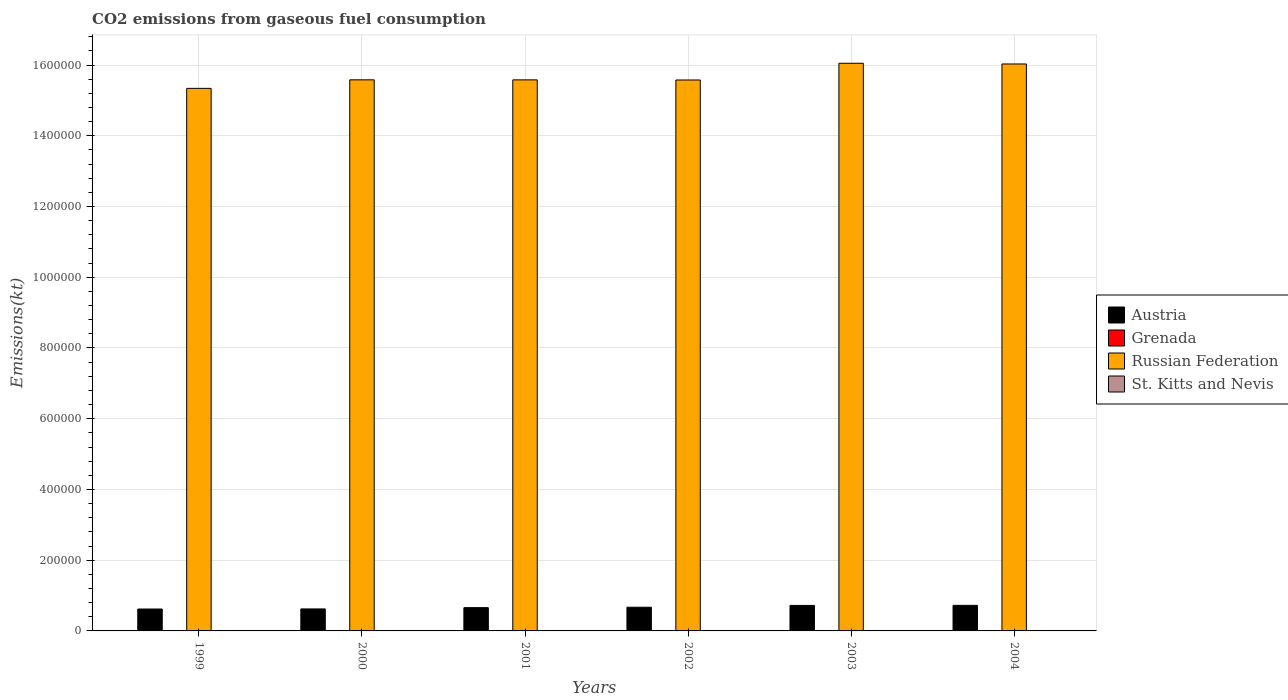How many different coloured bars are there?
Make the answer very short. 4. How many groups of bars are there?
Your answer should be compact. 6. Are the number of bars on each tick of the X-axis equal?
Provide a succinct answer. Yes. How many bars are there on the 3rd tick from the right?
Make the answer very short. 4. What is the amount of CO2 emitted in Austria in 2002?
Your answer should be very brief. 6.70e+04. Across all years, what is the maximum amount of CO2 emitted in Grenada?
Provide a succinct answer. 216.35. Across all years, what is the minimum amount of CO2 emitted in Russian Federation?
Your response must be concise. 1.53e+06. In which year was the amount of CO2 emitted in St. Kitts and Nevis maximum?
Offer a terse response. 2004. In which year was the amount of CO2 emitted in St. Kitts and Nevis minimum?
Offer a very short reply. 1999. What is the total amount of CO2 emitted in St. Kitts and Nevis in the graph?
Your response must be concise. 1034.09. What is the difference between the amount of CO2 emitted in Austria in 2002 and that in 2003?
Keep it short and to the point. -5097.13. What is the difference between the amount of CO2 emitted in Russian Federation in 2003 and the amount of CO2 emitted in Grenada in 1999?
Offer a very short reply. 1.60e+06. What is the average amount of CO2 emitted in Grenada per year?
Your response must be concise. 201.07. In the year 2003, what is the difference between the amount of CO2 emitted in Grenada and amount of CO2 emitted in Austria?
Keep it short and to the point. -7.19e+04. What is the ratio of the amount of CO2 emitted in St. Kitts and Nevis in 2002 to that in 2003?
Ensure brevity in your answer.  0.9. What is the difference between the highest and the second highest amount of CO2 emitted in Grenada?
Give a very brief answer. 11. What is the difference between the highest and the lowest amount of CO2 emitted in Austria?
Your answer should be compact. 1.04e+04. In how many years, is the amount of CO2 emitted in Grenada greater than the average amount of CO2 emitted in Grenada taken over all years?
Your answer should be very brief. 3. Is the sum of the amount of CO2 emitted in Grenada in 2000 and 2001 greater than the maximum amount of CO2 emitted in Austria across all years?
Provide a succinct answer. No. What does the 1st bar from the right in 2003 represents?
Provide a short and direct response. St. Kitts and Nevis. Is it the case that in every year, the sum of the amount of CO2 emitted in Grenada and amount of CO2 emitted in St. Kitts and Nevis is greater than the amount of CO2 emitted in Austria?
Offer a very short reply. No. How many years are there in the graph?
Ensure brevity in your answer.  6. Does the graph contain any zero values?
Ensure brevity in your answer.  No. Does the graph contain grids?
Ensure brevity in your answer.  Yes. How many legend labels are there?
Provide a short and direct response. 4. What is the title of the graph?
Ensure brevity in your answer.  CO2 emissions from gaseous fuel consumption. What is the label or title of the X-axis?
Your response must be concise. Years. What is the label or title of the Y-axis?
Offer a very short reply. Emissions(kt). What is the Emissions(kt) of Austria in 1999?
Offer a terse response. 6.19e+04. What is the Emissions(kt) of Grenada in 1999?
Make the answer very short. 194.35. What is the Emissions(kt) in Russian Federation in 1999?
Give a very brief answer. 1.53e+06. What is the Emissions(kt) of St. Kitts and Nevis in 1999?
Provide a succinct answer. 102.68. What is the Emissions(kt) of Austria in 2000?
Your answer should be very brief. 6.22e+04. What is the Emissions(kt) of Grenada in 2000?
Keep it short and to the point. 190.68. What is the Emissions(kt) of Russian Federation in 2000?
Provide a short and direct response. 1.56e+06. What is the Emissions(kt) of St. Kitts and Nevis in 2000?
Your answer should be compact. 102.68. What is the Emissions(kt) of Austria in 2001?
Make the answer very short. 6.58e+04. What is the Emissions(kt) of Grenada in 2001?
Ensure brevity in your answer.  194.35. What is the Emissions(kt) in Russian Federation in 2001?
Your response must be concise. 1.56e+06. What is the Emissions(kt) in St. Kitts and Nevis in 2001?
Provide a succinct answer. 183.35. What is the Emissions(kt) in Austria in 2002?
Provide a succinct answer. 6.70e+04. What is the Emissions(kt) of Grenada in 2002?
Offer a terse response. 205.35. What is the Emissions(kt) of Russian Federation in 2002?
Offer a very short reply. 1.56e+06. What is the Emissions(kt) of St. Kitts and Nevis in 2002?
Give a very brief answer. 198.02. What is the Emissions(kt) of Austria in 2003?
Keep it short and to the point. 7.21e+04. What is the Emissions(kt) in Grenada in 2003?
Make the answer very short. 216.35. What is the Emissions(kt) in Russian Federation in 2003?
Your response must be concise. 1.60e+06. What is the Emissions(kt) in St. Kitts and Nevis in 2003?
Make the answer very short. 220.02. What is the Emissions(kt) in Austria in 2004?
Ensure brevity in your answer.  7.23e+04. What is the Emissions(kt) of Grenada in 2004?
Ensure brevity in your answer.  205.35. What is the Emissions(kt) of Russian Federation in 2004?
Your response must be concise. 1.60e+06. What is the Emissions(kt) in St. Kitts and Nevis in 2004?
Give a very brief answer. 227.35. Across all years, what is the maximum Emissions(kt) in Austria?
Keep it short and to the point. 7.23e+04. Across all years, what is the maximum Emissions(kt) in Grenada?
Your answer should be very brief. 216.35. Across all years, what is the maximum Emissions(kt) of Russian Federation?
Your answer should be compact. 1.60e+06. Across all years, what is the maximum Emissions(kt) of St. Kitts and Nevis?
Ensure brevity in your answer.  227.35. Across all years, what is the minimum Emissions(kt) in Austria?
Provide a short and direct response. 6.19e+04. Across all years, what is the minimum Emissions(kt) in Grenada?
Keep it short and to the point. 190.68. Across all years, what is the minimum Emissions(kt) of Russian Federation?
Offer a very short reply. 1.53e+06. Across all years, what is the minimum Emissions(kt) in St. Kitts and Nevis?
Provide a short and direct response. 102.68. What is the total Emissions(kt) of Austria in the graph?
Provide a short and direct response. 4.01e+05. What is the total Emissions(kt) of Grenada in the graph?
Provide a succinct answer. 1206.44. What is the total Emissions(kt) of Russian Federation in the graph?
Your answer should be compact. 9.42e+06. What is the total Emissions(kt) in St. Kitts and Nevis in the graph?
Ensure brevity in your answer.  1034.09. What is the difference between the Emissions(kt) of Austria in 1999 and that in 2000?
Provide a short and direct response. -271.36. What is the difference between the Emissions(kt) of Grenada in 1999 and that in 2000?
Ensure brevity in your answer.  3.67. What is the difference between the Emissions(kt) of Russian Federation in 1999 and that in 2000?
Provide a succinct answer. -2.41e+04. What is the difference between the Emissions(kt) in Austria in 1999 and that in 2001?
Provide a short and direct response. -3868.68. What is the difference between the Emissions(kt) in Russian Federation in 1999 and that in 2001?
Keep it short and to the point. -2.40e+04. What is the difference between the Emissions(kt) of St. Kitts and Nevis in 1999 and that in 2001?
Offer a terse response. -80.67. What is the difference between the Emissions(kt) of Austria in 1999 and that in 2002?
Your answer should be compact. -5060.46. What is the difference between the Emissions(kt) of Grenada in 1999 and that in 2002?
Give a very brief answer. -11. What is the difference between the Emissions(kt) in Russian Federation in 1999 and that in 2002?
Your answer should be very brief. -2.37e+04. What is the difference between the Emissions(kt) of St. Kitts and Nevis in 1999 and that in 2002?
Provide a succinct answer. -95.34. What is the difference between the Emissions(kt) of Austria in 1999 and that in 2003?
Give a very brief answer. -1.02e+04. What is the difference between the Emissions(kt) of Grenada in 1999 and that in 2003?
Keep it short and to the point. -22. What is the difference between the Emissions(kt) in Russian Federation in 1999 and that in 2003?
Provide a short and direct response. -7.10e+04. What is the difference between the Emissions(kt) in St. Kitts and Nevis in 1999 and that in 2003?
Offer a very short reply. -117.34. What is the difference between the Emissions(kt) in Austria in 1999 and that in 2004?
Give a very brief answer. -1.04e+04. What is the difference between the Emissions(kt) of Grenada in 1999 and that in 2004?
Provide a succinct answer. -11. What is the difference between the Emissions(kt) of Russian Federation in 1999 and that in 2004?
Make the answer very short. -6.90e+04. What is the difference between the Emissions(kt) of St. Kitts and Nevis in 1999 and that in 2004?
Provide a short and direct response. -124.68. What is the difference between the Emissions(kt) in Austria in 2000 and that in 2001?
Your response must be concise. -3597.33. What is the difference between the Emissions(kt) of Grenada in 2000 and that in 2001?
Your answer should be very brief. -3.67. What is the difference between the Emissions(kt) in Russian Federation in 2000 and that in 2001?
Make the answer very short. 110.01. What is the difference between the Emissions(kt) in St. Kitts and Nevis in 2000 and that in 2001?
Your response must be concise. -80.67. What is the difference between the Emissions(kt) in Austria in 2000 and that in 2002?
Your answer should be compact. -4789.1. What is the difference between the Emissions(kt) of Grenada in 2000 and that in 2002?
Provide a short and direct response. -14.67. What is the difference between the Emissions(kt) in Russian Federation in 2000 and that in 2002?
Give a very brief answer. 451.04. What is the difference between the Emissions(kt) of St. Kitts and Nevis in 2000 and that in 2002?
Provide a succinct answer. -95.34. What is the difference between the Emissions(kt) in Austria in 2000 and that in 2003?
Keep it short and to the point. -9886.23. What is the difference between the Emissions(kt) of Grenada in 2000 and that in 2003?
Provide a short and direct response. -25.67. What is the difference between the Emissions(kt) of Russian Federation in 2000 and that in 2003?
Offer a very short reply. -4.69e+04. What is the difference between the Emissions(kt) of St. Kitts and Nevis in 2000 and that in 2003?
Offer a terse response. -117.34. What is the difference between the Emissions(kt) in Austria in 2000 and that in 2004?
Ensure brevity in your answer.  -1.01e+04. What is the difference between the Emissions(kt) in Grenada in 2000 and that in 2004?
Your response must be concise. -14.67. What is the difference between the Emissions(kt) of Russian Federation in 2000 and that in 2004?
Offer a very short reply. -4.48e+04. What is the difference between the Emissions(kt) in St. Kitts and Nevis in 2000 and that in 2004?
Keep it short and to the point. -124.68. What is the difference between the Emissions(kt) in Austria in 2001 and that in 2002?
Offer a terse response. -1191.78. What is the difference between the Emissions(kt) of Grenada in 2001 and that in 2002?
Your answer should be compact. -11. What is the difference between the Emissions(kt) in Russian Federation in 2001 and that in 2002?
Make the answer very short. 341.03. What is the difference between the Emissions(kt) in St. Kitts and Nevis in 2001 and that in 2002?
Offer a terse response. -14.67. What is the difference between the Emissions(kt) in Austria in 2001 and that in 2003?
Provide a succinct answer. -6288.9. What is the difference between the Emissions(kt) of Grenada in 2001 and that in 2003?
Your answer should be compact. -22. What is the difference between the Emissions(kt) of Russian Federation in 2001 and that in 2003?
Your response must be concise. -4.70e+04. What is the difference between the Emissions(kt) in St. Kitts and Nevis in 2001 and that in 2003?
Your answer should be compact. -36.67. What is the difference between the Emissions(kt) of Austria in 2001 and that in 2004?
Keep it short and to the point. -6486.92. What is the difference between the Emissions(kt) in Grenada in 2001 and that in 2004?
Your answer should be very brief. -11. What is the difference between the Emissions(kt) of Russian Federation in 2001 and that in 2004?
Offer a terse response. -4.50e+04. What is the difference between the Emissions(kt) of St. Kitts and Nevis in 2001 and that in 2004?
Provide a succinct answer. -44. What is the difference between the Emissions(kt) in Austria in 2002 and that in 2003?
Offer a very short reply. -5097.13. What is the difference between the Emissions(kt) of Grenada in 2002 and that in 2003?
Your answer should be very brief. -11. What is the difference between the Emissions(kt) of Russian Federation in 2002 and that in 2003?
Make the answer very short. -4.73e+04. What is the difference between the Emissions(kt) of St. Kitts and Nevis in 2002 and that in 2003?
Offer a terse response. -22. What is the difference between the Emissions(kt) of Austria in 2002 and that in 2004?
Make the answer very short. -5295.15. What is the difference between the Emissions(kt) in Grenada in 2002 and that in 2004?
Provide a succinct answer. 0. What is the difference between the Emissions(kt) in Russian Federation in 2002 and that in 2004?
Your answer should be compact. -4.53e+04. What is the difference between the Emissions(kt) in St. Kitts and Nevis in 2002 and that in 2004?
Make the answer very short. -29.34. What is the difference between the Emissions(kt) of Austria in 2003 and that in 2004?
Offer a terse response. -198.02. What is the difference between the Emissions(kt) in Grenada in 2003 and that in 2004?
Ensure brevity in your answer.  11. What is the difference between the Emissions(kt) in Russian Federation in 2003 and that in 2004?
Give a very brief answer. 2013.18. What is the difference between the Emissions(kt) of St. Kitts and Nevis in 2003 and that in 2004?
Your response must be concise. -7.33. What is the difference between the Emissions(kt) of Austria in 1999 and the Emissions(kt) of Grenada in 2000?
Ensure brevity in your answer.  6.17e+04. What is the difference between the Emissions(kt) of Austria in 1999 and the Emissions(kt) of Russian Federation in 2000?
Your answer should be very brief. -1.50e+06. What is the difference between the Emissions(kt) of Austria in 1999 and the Emissions(kt) of St. Kitts and Nevis in 2000?
Your answer should be compact. 6.18e+04. What is the difference between the Emissions(kt) in Grenada in 1999 and the Emissions(kt) in Russian Federation in 2000?
Your response must be concise. -1.56e+06. What is the difference between the Emissions(kt) of Grenada in 1999 and the Emissions(kt) of St. Kitts and Nevis in 2000?
Provide a succinct answer. 91.67. What is the difference between the Emissions(kt) of Russian Federation in 1999 and the Emissions(kt) of St. Kitts and Nevis in 2000?
Provide a short and direct response. 1.53e+06. What is the difference between the Emissions(kt) of Austria in 1999 and the Emissions(kt) of Grenada in 2001?
Make the answer very short. 6.17e+04. What is the difference between the Emissions(kt) in Austria in 1999 and the Emissions(kt) in Russian Federation in 2001?
Give a very brief answer. -1.50e+06. What is the difference between the Emissions(kt) in Austria in 1999 and the Emissions(kt) in St. Kitts and Nevis in 2001?
Provide a short and direct response. 6.17e+04. What is the difference between the Emissions(kt) of Grenada in 1999 and the Emissions(kt) of Russian Federation in 2001?
Your answer should be compact. -1.56e+06. What is the difference between the Emissions(kt) of Grenada in 1999 and the Emissions(kt) of St. Kitts and Nevis in 2001?
Your response must be concise. 11. What is the difference between the Emissions(kt) in Russian Federation in 1999 and the Emissions(kt) in St. Kitts and Nevis in 2001?
Provide a short and direct response. 1.53e+06. What is the difference between the Emissions(kt) of Austria in 1999 and the Emissions(kt) of Grenada in 2002?
Ensure brevity in your answer.  6.17e+04. What is the difference between the Emissions(kt) in Austria in 1999 and the Emissions(kt) in Russian Federation in 2002?
Make the answer very short. -1.50e+06. What is the difference between the Emissions(kt) in Austria in 1999 and the Emissions(kt) in St. Kitts and Nevis in 2002?
Your answer should be very brief. 6.17e+04. What is the difference between the Emissions(kt) of Grenada in 1999 and the Emissions(kt) of Russian Federation in 2002?
Provide a succinct answer. -1.56e+06. What is the difference between the Emissions(kt) in Grenada in 1999 and the Emissions(kt) in St. Kitts and Nevis in 2002?
Make the answer very short. -3.67. What is the difference between the Emissions(kt) in Russian Federation in 1999 and the Emissions(kt) in St. Kitts and Nevis in 2002?
Make the answer very short. 1.53e+06. What is the difference between the Emissions(kt) of Austria in 1999 and the Emissions(kt) of Grenada in 2003?
Ensure brevity in your answer.  6.17e+04. What is the difference between the Emissions(kt) of Austria in 1999 and the Emissions(kt) of Russian Federation in 2003?
Your response must be concise. -1.54e+06. What is the difference between the Emissions(kt) in Austria in 1999 and the Emissions(kt) in St. Kitts and Nevis in 2003?
Your answer should be very brief. 6.17e+04. What is the difference between the Emissions(kt) in Grenada in 1999 and the Emissions(kt) in Russian Federation in 2003?
Your answer should be very brief. -1.60e+06. What is the difference between the Emissions(kt) in Grenada in 1999 and the Emissions(kt) in St. Kitts and Nevis in 2003?
Ensure brevity in your answer.  -25.67. What is the difference between the Emissions(kt) in Russian Federation in 1999 and the Emissions(kt) in St. Kitts and Nevis in 2003?
Your answer should be compact. 1.53e+06. What is the difference between the Emissions(kt) in Austria in 1999 and the Emissions(kt) in Grenada in 2004?
Give a very brief answer. 6.17e+04. What is the difference between the Emissions(kt) in Austria in 1999 and the Emissions(kt) in Russian Federation in 2004?
Your answer should be compact. -1.54e+06. What is the difference between the Emissions(kt) in Austria in 1999 and the Emissions(kt) in St. Kitts and Nevis in 2004?
Provide a short and direct response. 6.17e+04. What is the difference between the Emissions(kt) of Grenada in 1999 and the Emissions(kt) of Russian Federation in 2004?
Offer a very short reply. -1.60e+06. What is the difference between the Emissions(kt) in Grenada in 1999 and the Emissions(kt) in St. Kitts and Nevis in 2004?
Offer a very short reply. -33. What is the difference between the Emissions(kt) in Russian Federation in 1999 and the Emissions(kt) in St. Kitts and Nevis in 2004?
Make the answer very short. 1.53e+06. What is the difference between the Emissions(kt) in Austria in 2000 and the Emissions(kt) in Grenada in 2001?
Ensure brevity in your answer.  6.20e+04. What is the difference between the Emissions(kt) in Austria in 2000 and the Emissions(kt) in Russian Federation in 2001?
Your answer should be very brief. -1.50e+06. What is the difference between the Emissions(kt) in Austria in 2000 and the Emissions(kt) in St. Kitts and Nevis in 2001?
Your answer should be very brief. 6.20e+04. What is the difference between the Emissions(kt) in Grenada in 2000 and the Emissions(kt) in Russian Federation in 2001?
Your answer should be compact. -1.56e+06. What is the difference between the Emissions(kt) in Grenada in 2000 and the Emissions(kt) in St. Kitts and Nevis in 2001?
Ensure brevity in your answer.  7.33. What is the difference between the Emissions(kt) of Russian Federation in 2000 and the Emissions(kt) of St. Kitts and Nevis in 2001?
Your answer should be compact. 1.56e+06. What is the difference between the Emissions(kt) in Austria in 2000 and the Emissions(kt) in Grenada in 2002?
Provide a succinct answer. 6.20e+04. What is the difference between the Emissions(kt) of Austria in 2000 and the Emissions(kt) of Russian Federation in 2002?
Keep it short and to the point. -1.50e+06. What is the difference between the Emissions(kt) of Austria in 2000 and the Emissions(kt) of St. Kitts and Nevis in 2002?
Offer a very short reply. 6.20e+04. What is the difference between the Emissions(kt) of Grenada in 2000 and the Emissions(kt) of Russian Federation in 2002?
Provide a succinct answer. -1.56e+06. What is the difference between the Emissions(kt) of Grenada in 2000 and the Emissions(kt) of St. Kitts and Nevis in 2002?
Your answer should be very brief. -7.33. What is the difference between the Emissions(kt) in Russian Federation in 2000 and the Emissions(kt) in St. Kitts and Nevis in 2002?
Provide a short and direct response. 1.56e+06. What is the difference between the Emissions(kt) in Austria in 2000 and the Emissions(kt) in Grenada in 2003?
Your answer should be compact. 6.20e+04. What is the difference between the Emissions(kt) of Austria in 2000 and the Emissions(kt) of Russian Federation in 2003?
Your answer should be very brief. -1.54e+06. What is the difference between the Emissions(kt) of Austria in 2000 and the Emissions(kt) of St. Kitts and Nevis in 2003?
Keep it short and to the point. 6.20e+04. What is the difference between the Emissions(kt) of Grenada in 2000 and the Emissions(kt) of Russian Federation in 2003?
Ensure brevity in your answer.  -1.60e+06. What is the difference between the Emissions(kt) in Grenada in 2000 and the Emissions(kt) in St. Kitts and Nevis in 2003?
Provide a succinct answer. -29.34. What is the difference between the Emissions(kt) in Russian Federation in 2000 and the Emissions(kt) in St. Kitts and Nevis in 2003?
Your answer should be compact. 1.56e+06. What is the difference between the Emissions(kt) of Austria in 2000 and the Emissions(kt) of Grenada in 2004?
Keep it short and to the point. 6.20e+04. What is the difference between the Emissions(kt) of Austria in 2000 and the Emissions(kt) of Russian Federation in 2004?
Make the answer very short. -1.54e+06. What is the difference between the Emissions(kt) of Austria in 2000 and the Emissions(kt) of St. Kitts and Nevis in 2004?
Ensure brevity in your answer.  6.20e+04. What is the difference between the Emissions(kt) of Grenada in 2000 and the Emissions(kt) of Russian Federation in 2004?
Offer a very short reply. -1.60e+06. What is the difference between the Emissions(kt) in Grenada in 2000 and the Emissions(kt) in St. Kitts and Nevis in 2004?
Your response must be concise. -36.67. What is the difference between the Emissions(kt) in Russian Federation in 2000 and the Emissions(kt) in St. Kitts and Nevis in 2004?
Offer a terse response. 1.56e+06. What is the difference between the Emissions(kt) of Austria in 2001 and the Emissions(kt) of Grenada in 2002?
Offer a very short reply. 6.56e+04. What is the difference between the Emissions(kt) of Austria in 2001 and the Emissions(kt) of Russian Federation in 2002?
Give a very brief answer. -1.49e+06. What is the difference between the Emissions(kt) in Austria in 2001 and the Emissions(kt) in St. Kitts and Nevis in 2002?
Ensure brevity in your answer.  6.56e+04. What is the difference between the Emissions(kt) in Grenada in 2001 and the Emissions(kt) in Russian Federation in 2002?
Make the answer very short. -1.56e+06. What is the difference between the Emissions(kt) of Grenada in 2001 and the Emissions(kt) of St. Kitts and Nevis in 2002?
Your answer should be very brief. -3.67. What is the difference between the Emissions(kt) in Russian Federation in 2001 and the Emissions(kt) in St. Kitts and Nevis in 2002?
Your response must be concise. 1.56e+06. What is the difference between the Emissions(kt) in Austria in 2001 and the Emissions(kt) in Grenada in 2003?
Provide a succinct answer. 6.56e+04. What is the difference between the Emissions(kt) in Austria in 2001 and the Emissions(kt) in Russian Federation in 2003?
Provide a short and direct response. -1.54e+06. What is the difference between the Emissions(kt) of Austria in 2001 and the Emissions(kt) of St. Kitts and Nevis in 2003?
Provide a succinct answer. 6.56e+04. What is the difference between the Emissions(kt) in Grenada in 2001 and the Emissions(kt) in Russian Federation in 2003?
Offer a very short reply. -1.60e+06. What is the difference between the Emissions(kt) of Grenada in 2001 and the Emissions(kt) of St. Kitts and Nevis in 2003?
Provide a succinct answer. -25.67. What is the difference between the Emissions(kt) of Russian Federation in 2001 and the Emissions(kt) of St. Kitts and Nevis in 2003?
Your answer should be very brief. 1.56e+06. What is the difference between the Emissions(kt) in Austria in 2001 and the Emissions(kt) in Grenada in 2004?
Your answer should be compact. 6.56e+04. What is the difference between the Emissions(kt) of Austria in 2001 and the Emissions(kt) of Russian Federation in 2004?
Provide a short and direct response. -1.54e+06. What is the difference between the Emissions(kt) of Austria in 2001 and the Emissions(kt) of St. Kitts and Nevis in 2004?
Your answer should be compact. 6.56e+04. What is the difference between the Emissions(kt) of Grenada in 2001 and the Emissions(kt) of Russian Federation in 2004?
Offer a very short reply. -1.60e+06. What is the difference between the Emissions(kt) of Grenada in 2001 and the Emissions(kt) of St. Kitts and Nevis in 2004?
Provide a succinct answer. -33. What is the difference between the Emissions(kt) of Russian Federation in 2001 and the Emissions(kt) of St. Kitts and Nevis in 2004?
Make the answer very short. 1.56e+06. What is the difference between the Emissions(kt) in Austria in 2002 and the Emissions(kt) in Grenada in 2003?
Provide a succinct answer. 6.68e+04. What is the difference between the Emissions(kt) of Austria in 2002 and the Emissions(kt) of Russian Federation in 2003?
Your answer should be very brief. -1.54e+06. What is the difference between the Emissions(kt) in Austria in 2002 and the Emissions(kt) in St. Kitts and Nevis in 2003?
Give a very brief answer. 6.68e+04. What is the difference between the Emissions(kt) of Grenada in 2002 and the Emissions(kt) of Russian Federation in 2003?
Your answer should be compact. -1.60e+06. What is the difference between the Emissions(kt) of Grenada in 2002 and the Emissions(kt) of St. Kitts and Nevis in 2003?
Provide a succinct answer. -14.67. What is the difference between the Emissions(kt) of Russian Federation in 2002 and the Emissions(kt) of St. Kitts and Nevis in 2003?
Your answer should be very brief. 1.56e+06. What is the difference between the Emissions(kt) in Austria in 2002 and the Emissions(kt) in Grenada in 2004?
Your answer should be compact. 6.68e+04. What is the difference between the Emissions(kt) of Austria in 2002 and the Emissions(kt) of Russian Federation in 2004?
Make the answer very short. -1.54e+06. What is the difference between the Emissions(kt) of Austria in 2002 and the Emissions(kt) of St. Kitts and Nevis in 2004?
Ensure brevity in your answer.  6.68e+04. What is the difference between the Emissions(kt) in Grenada in 2002 and the Emissions(kt) in Russian Federation in 2004?
Offer a very short reply. -1.60e+06. What is the difference between the Emissions(kt) of Grenada in 2002 and the Emissions(kt) of St. Kitts and Nevis in 2004?
Provide a short and direct response. -22. What is the difference between the Emissions(kt) in Russian Federation in 2002 and the Emissions(kt) in St. Kitts and Nevis in 2004?
Provide a short and direct response. 1.56e+06. What is the difference between the Emissions(kt) in Austria in 2003 and the Emissions(kt) in Grenada in 2004?
Your answer should be compact. 7.19e+04. What is the difference between the Emissions(kt) of Austria in 2003 and the Emissions(kt) of Russian Federation in 2004?
Offer a terse response. -1.53e+06. What is the difference between the Emissions(kt) of Austria in 2003 and the Emissions(kt) of St. Kitts and Nevis in 2004?
Give a very brief answer. 7.18e+04. What is the difference between the Emissions(kt) in Grenada in 2003 and the Emissions(kt) in Russian Federation in 2004?
Your response must be concise. -1.60e+06. What is the difference between the Emissions(kt) of Grenada in 2003 and the Emissions(kt) of St. Kitts and Nevis in 2004?
Your answer should be very brief. -11. What is the difference between the Emissions(kt) of Russian Federation in 2003 and the Emissions(kt) of St. Kitts and Nevis in 2004?
Your answer should be compact. 1.60e+06. What is the average Emissions(kt) in Austria per year?
Provide a short and direct response. 6.69e+04. What is the average Emissions(kt) of Grenada per year?
Ensure brevity in your answer.  201.07. What is the average Emissions(kt) in Russian Federation per year?
Offer a terse response. 1.57e+06. What is the average Emissions(kt) in St. Kitts and Nevis per year?
Keep it short and to the point. 172.35. In the year 1999, what is the difference between the Emissions(kt) of Austria and Emissions(kt) of Grenada?
Make the answer very short. 6.17e+04. In the year 1999, what is the difference between the Emissions(kt) in Austria and Emissions(kt) in Russian Federation?
Make the answer very short. -1.47e+06. In the year 1999, what is the difference between the Emissions(kt) in Austria and Emissions(kt) in St. Kitts and Nevis?
Your response must be concise. 6.18e+04. In the year 1999, what is the difference between the Emissions(kt) of Grenada and Emissions(kt) of Russian Federation?
Your answer should be very brief. -1.53e+06. In the year 1999, what is the difference between the Emissions(kt) of Grenada and Emissions(kt) of St. Kitts and Nevis?
Ensure brevity in your answer.  91.67. In the year 1999, what is the difference between the Emissions(kt) of Russian Federation and Emissions(kt) of St. Kitts and Nevis?
Give a very brief answer. 1.53e+06. In the year 2000, what is the difference between the Emissions(kt) in Austria and Emissions(kt) in Grenada?
Your response must be concise. 6.20e+04. In the year 2000, what is the difference between the Emissions(kt) in Austria and Emissions(kt) in Russian Federation?
Offer a terse response. -1.50e+06. In the year 2000, what is the difference between the Emissions(kt) of Austria and Emissions(kt) of St. Kitts and Nevis?
Offer a terse response. 6.21e+04. In the year 2000, what is the difference between the Emissions(kt) of Grenada and Emissions(kt) of Russian Federation?
Your answer should be compact. -1.56e+06. In the year 2000, what is the difference between the Emissions(kt) of Grenada and Emissions(kt) of St. Kitts and Nevis?
Offer a terse response. 88.01. In the year 2000, what is the difference between the Emissions(kt) of Russian Federation and Emissions(kt) of St. Kitts and Nevis?
Provide a short and direct response. 1.56e+06. In the year 2001, what is the difference between the Emissions(kt) in Austria and Emissions(kt) in Grenada?
Provide a succinct answer. 6.56e+04. In the year 2001, what is the difference between the Emissions(kt) in Austria and Emissions(kt) in Russian Federation?
Ensure brevity in your answer.  -1.49e+06. In the year 2001, what is the difference between the Emissions(kt) in Austria and Emissions(kt) in St. Kitts and Nevis?
Your response must be concise. 6.56e+04. In the year 2001, what is the difference between the Emissions(kt) in Grenada and Emissions(kt) in Russian Federation?
Your response must be concise. -1.56e+06. In the year 2001, what is the difference between the Emissions(kt) in Grenada and Emissions(kt) in St. Kitts and Nevis?
Make the answer very short. 11. In the year 2001, what is the difference between the Emissions(kt) in Russian Federation and Emissions(kt) in St. Kitts and Nevis?
Give a very brief answer. 1.56e+06. In the year 2002, what is the difference between the Emissions(kt) in Austria and Emissions(kt) in Grenada?
Give a very brief answer. 6.68e+04. In the year 2002, what is the difference between the Emissions(kt) of Austria and Emissions(kt) of Russian Federation?
Give a very brief answer. -1.49e+06. In the year 2002, what is the difference between the Emissions(kt) in Austria and Emissions(kt) in St. Kitts and Nevis?
Provide a succinct answer. 6.68e+04. In the year 2002, what is the difference between the Emissions(kt) in Grenada and Emissions(kt) in Russian Federation?
Give a very brief answer. -1.56e+06. In the year 2002, what is the difference between the Emissions(kt) in Grenada and Emissions(kt) in St. Kitts and Nevis?
Provide a short and direct response. 7.33. In the year 2002, what is the difference between the Emissions(kt) of Russian Federation and Emissions(kt) of St. Kitts and Nevis?
Provide a short and direct response. 1.56e+06. In the year 2003, what is the difference between the Emissions(kt) of Austria and Emissions(kt) of Grenada?
Your answer should be very brief. 7.19e+04. In the year 2003, what is the difference between the Emissions(kt) of Austria and Emissions(kt) of Russian Federation?
Offer a terse response. -1.53e+06. In the year 2003, what is the difference between the Emissions(kt) of Austria and Emissions(kt) of St. Kitts and Nevis?
Provide a short and direct response. 7.19e+04. In the year 2003, what is the difference between the Emissions(kt) in Grenada and Emissions(kt) in Russian Federation?
Ensure brevity in your answer.  -1.60e+06. In the year 2003, what is the difference between the Emissions(kt) of Grenada and Emissions(kt) of St. Kitts and Nevis?
Offer a terse response. -3.67. In the year 2003, what is the difference between the Emissions(kt) of Russian Federation and Emissions(kt) of St. Kitts and Nevis?
Your response must be concise. 1.60e+06. In the year 2004, what is the difference between the Emissions(kt) in Austria and Emissions(kt) in Grenada?
Your answer should be compact. 7.21e+04. In the year 2004, what is the difference between the Emissions(kt) in Austria and Emissions(kt) in Russian Federation?
Provide a short and direct response. -1.53e+06. In the year 2004, what is the difference between the Emissions(kt) of Austria and Emissions(kt) of St. Kitts and Nevis?
Make the answer very short. 7.20e+04. In the year 2004, what is the difference between the Emissions(kt) in Grenada and Emissions(kt) in Russian Federation?
Provide a succinct answer. -1.60e+06. In the year 2004, what is the difference between the Emissions(kt) of Grenada and Emissions(kt) of St. Kitts and Nevis?
Offer a very short reply. -22. In the year 2004, what is the difference between the Emissions(kt) of Russian Federation and Emissions(kt) of St. Kitts and Nevis?
Offer a terse response. 1.60e+06. What is the ratio of the Emissions(kt) of Grenada in 1999 to that in 2000?
Provide a succinct answer. 1.02. What is the ratio of the Emissions(kt) in Russian Federation in 1999 to that in 2000?
Offer a terse response. 0.98. What is the ratio of the Emissions(kt) in Russian Federation in 1999 to that in 2001?
Ensure brevity in your answer.  0.98. What is the ratio of the Emissions(kt) of St. Kitts and Nevis in 1999 to that in 2001?
Offer a terse response. 0.56. What is the ratio of the Emissions(kt) of Austria in 1999 to that in 2002?
Ensure brevity in your answer.  0.92. What is the ratio of the Emissions(kt) in Grenada in 1999 to that in 2002?
Keep it short and to the point. 0.95. What is the ratio of the Emissions(kt) in St. Kitts and Nevis in 1999 to that in 2002?
Offer a very short reply. 0.52. What is the ratio of the Emissions(kt) of Austria in 1999 to that in 2003?
Make the answer very short. 0.86. What is the ratio of the Emissions(kt) in Grenada in 1999 to that in 2003?
Your answer should be compact. 0.9. What is the ratio of the Emissions(kt) in Russian Federation in 1999 to that in 2003?
Provide a short and direct response. 0.96. What is the ratio of the Emissions(kt) in St. Kitts and Nevis in 1999 to that in 2003?
Your answer should be compact. 0.47. What is the ratio of the Emissions(kt) of Austria in 1999 to that in 2004?
Keep it short and to the point. 0.86. What is the ratio of the Emissions(kt) in Grenada in 1999 to that in 2004?
Provide a short and direct response. 0.95. What is the ratio of the Emissions(kt) in Russian Federation in 1999 to that in 2004?
Make the answer very short. 0.96. What is the ratio of the Emissions(kt) of St. Kitts and Nevis in 1999 to that in 2004?
Offer a terse response. 0.45. What is the ratio of the Emissions(kt) of Austria in 2000 to that in 2001?
Make the answer very short. 0.95. What is the ratio of the Emissions(kt) in Grenada in 2000 to that in 2001?
Keep it short and to the point. 0.98. What is the ratio of the Emissions(kt) of Russian Federation in 2000 to that in 2001?
Make the answer very short. 1. What is the ratio of the Emissions(kt) in St. Kitts and Nevis in 2000 to that in 2001?
Ensure brevity in your answer.  0.56. What is the ratio of the Emissions(kt) in Austria in 2000 to that in 2002?
Offer a very short reply. 0.93. What is the ratio of the Emissions(kt) of Grenada in 2000 to that in 2002?
Your answer should be very brief. 0.93. What is the ratio of the Emissions(kt) of St. Kitts and Nevis in 2000 to that in 2002?
Your response must be concise. 0.52. What is the ratio of the Emissions(kt) of Austria in 2000 to that in 2003?
Offer a terse response. 0.86. What is the ratio of the Emissions(kt) of Grenada in 2000 to that in 2003?
Offer a terse response. 0.88. What is the ratio of the Emissions(kt) in Russian Federation in 2000 to that in 2003?
Give a very brief answer. 0.97. What is the ratio of the Emissions(kt) in St. Kitts and Nevis in 2000 to that in 2003?
Your answer should be compact. 0.47. What is the ratio of the Emissions(kt) of Austria in 2000 to that in 2004?
Offer a very short reply. 0.86. What is the ratio of the Emissions(kt) of St. Kitts and Nevis in 2000 to that in 2004?
Ensure brevity in your answer.  0.45. What is the ratio of the Emissions(kt) in Austria in 2001 to that in 2002?
Provide a succinct answer. 0.98. What is the ratio of the Emissions(kt) of Grenada in 2001 to that in 2002?
Provide a succinct answer. 0.95. What is the ratio of the Emissions(kt) of Russian Federation in 2001 to that in 2002?
Give a very brief answer. 1. What is the ratio of the Emissions(kt) in St. Kitts and Nevis in 2001 to that in 2002?
Provide a short and direct response. 0.93. What is the ratio of the Emissions(kt) in Austria in 2001 to that in 2003?
Provide a succinct answer. 0.91. What is the ratio of the Emissions(kt) of Grenada in 2001 to that in 2003?
Ensure brevity in your answer.  0.9. What is the ratio of the Emissions(kt) in Russian Federation in 2001 to that in 2003?
Give a very brief answer. 0.97. What is the ratio of the Emissions(kt) of St. Kitts and Nevis in 2001 to that in 2003?
Make the answer very short. 0.83. What is the ratio of the Emissions(kt) of Austria in 2001 to that in 2004?
Your answer should be very brief. 0.91. What is the ratio of the Emissions(kt) of Grenada in 2001 to that in 2004?
Keep it short and to the point. 0.95. What is the ratio of the Emissions(kt) in Russian Federation in 2001 to that in 2004?
Your response must be concise. 0.97. What is the ratio of the Emissions(kt) in St. Kitts and Nevis in 2001 to that in 2004?
Your response must be concise. 0.81. What is the ratio of the Emissions(kt) of Austria in 2002 to that in 2003?
Provide a short and direct response. 0.93. What is the ratio of the Emissions(kt) in Grenada in 2002 to that in 2003?
Your answer should be very brief. 0.95. What is the ratio of the Emissions(kt) of Russian Federation in 2002 to that in 2003?
Give a very brief answer. 0.97. What is the ratio of the Emissions(kt) in Austria in 2002 to that in 2004?
Your response must be concise. 0.93. What is the ratio of the Emissions(kt) in Russian Federation in 2002 to that in 2004?
Your answer should be very brief. 0.97. What is the ratio of the Emissions(kt) in St. Kitts and Nevis in 2002 to that in 2004?
Offer a terse response. 0.87. What is the ratio of the Emissions(kt) of Grenada in 2003 to that in 2004?
Give a very brief answer. 1.05. What is the difference between the highest and the second highest Emissions(kt) of Austria?
Offer a very short reply. 198.02. What is the difference between the highest and the second highest Emissions(kt) of Grenada?
Make the answer very short. 11. What is the difference between the highest and the second highest Emissions(kt) in Russian Federation?
Provide a succinct answer. 2013.18. What is the difference between the highest and the second highest Emissions(kt) in St. Kitts and Nevis?
Your answer should be very brief. 7.33. What is the difference between the highest and the lowest Emissions(kt) in Austria?
Offer a terse response. 1.04e+04. What is the difference between the highest and the lowest Emissions(kt) of Grenada?
Keep it short and to the point. 25.67. What is the difference between the highest and the lowest Emissions(kt) of Russian Federation?
Keep it short and to the point. 7.10e+04. What is the difference between the highest and the lowest Emissions(kt) of St. Kitts and Nevis?
Your answer should be compact. 124.68. 